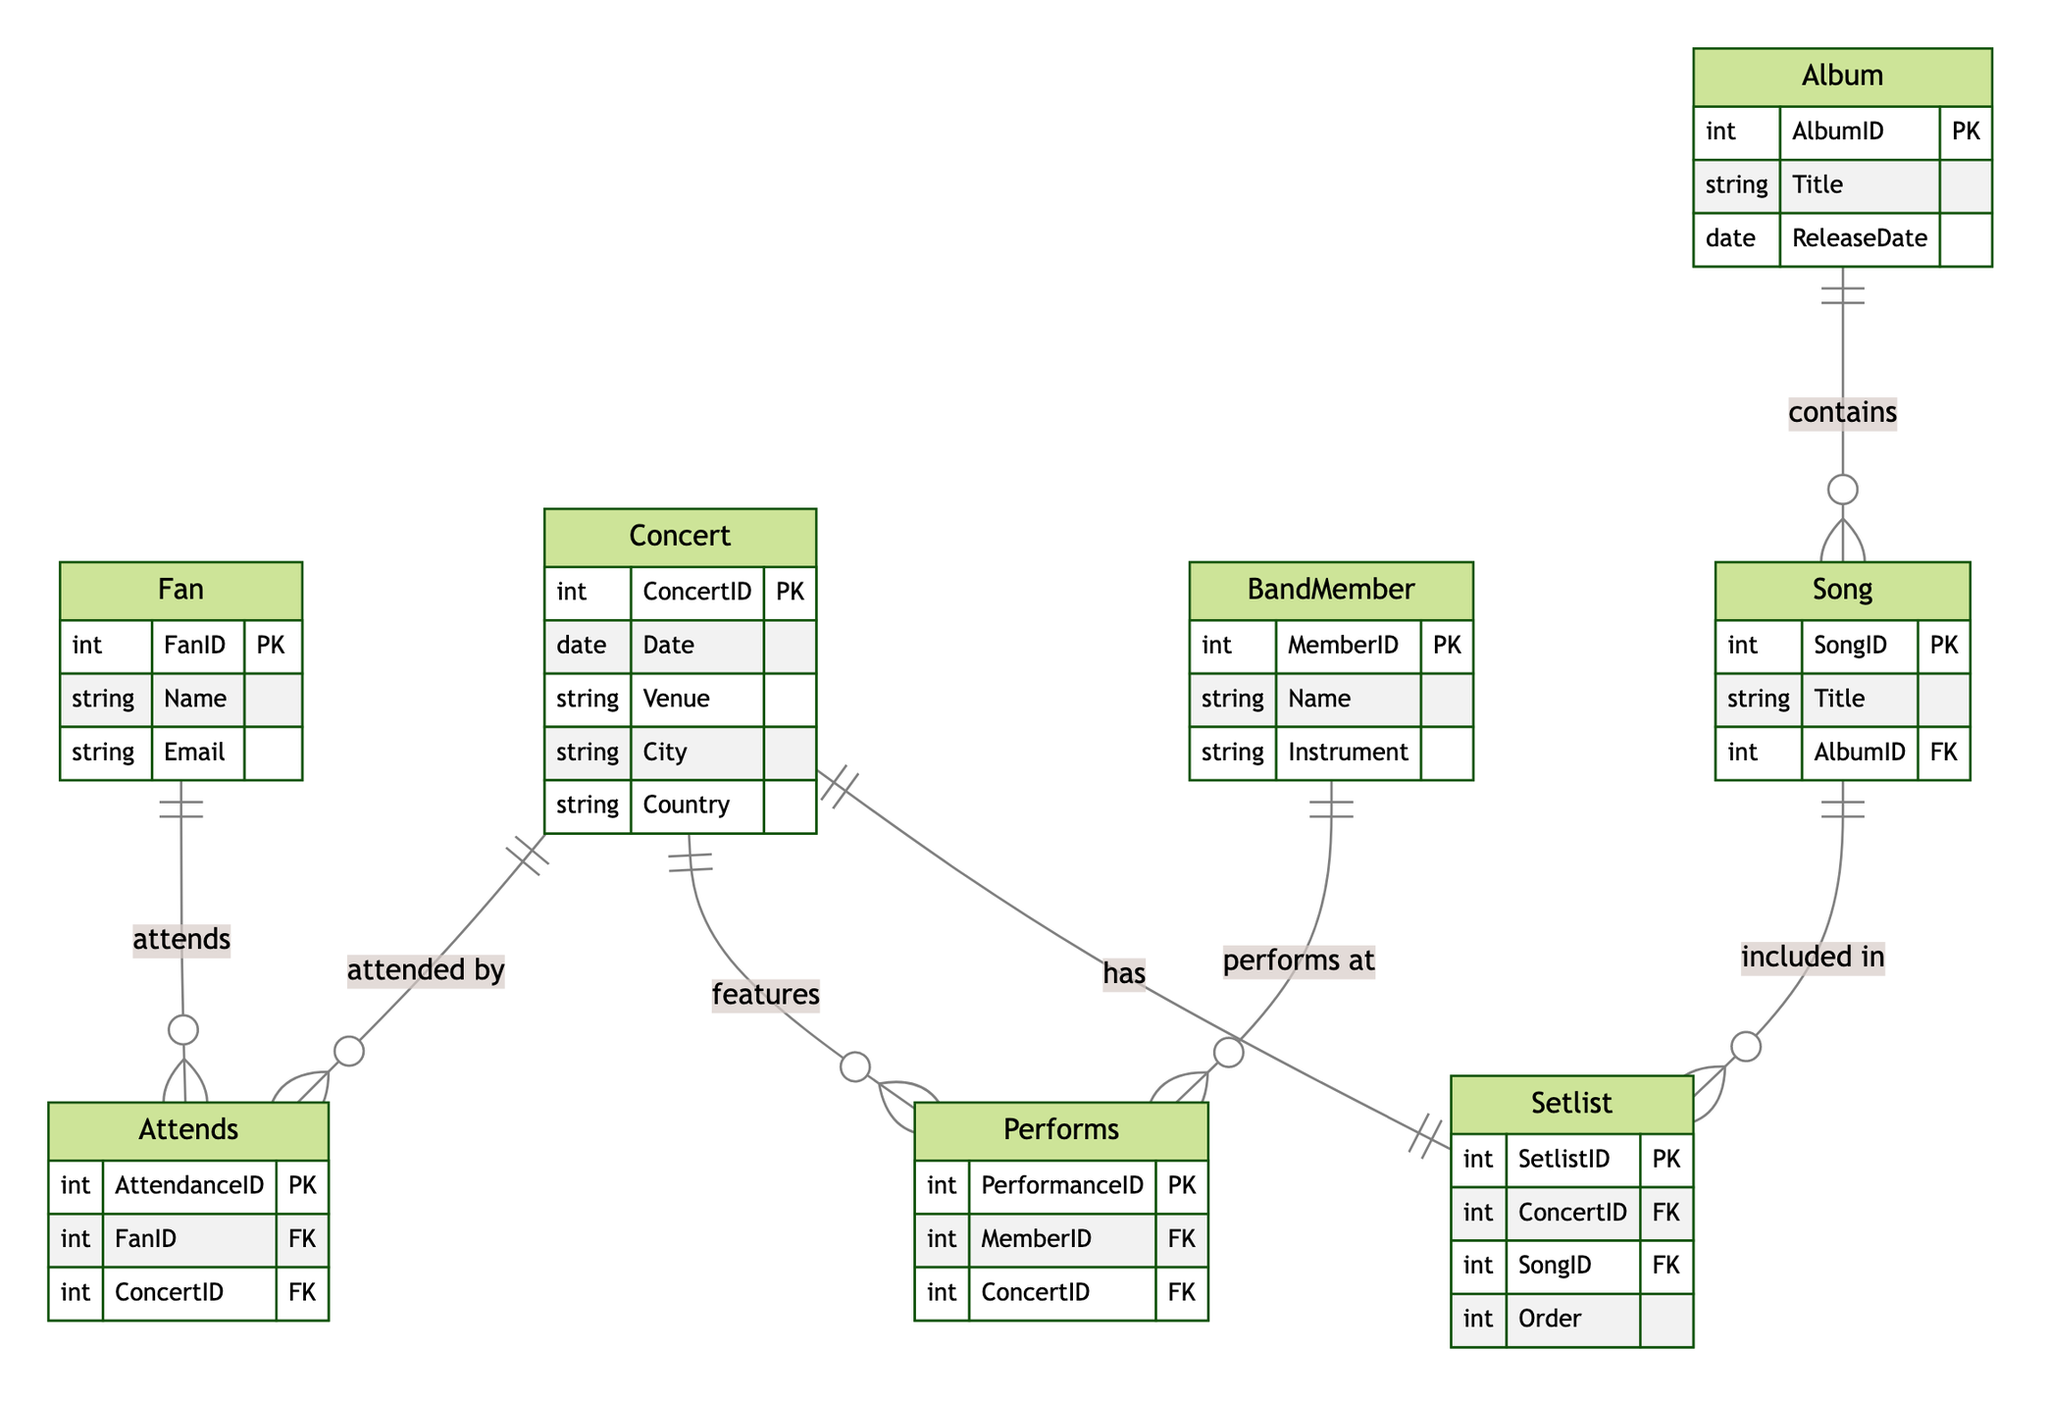What is the primary key of the Fan entity? The primary key of the Fan entity is specified as "FanID" in the diagram, which uniquely identifies each Fan in the system.
Answer: FanID How many attributes does the Concert entity have? The Concert entity contains 5 attributes: ConcertID, Date, Venue, City, and Country. By counting these attributes, we determine the total.
Answer: 5 What is the relationship between the Fan and Concert entities? The relationship is defined by the "Attends" entity, which connects Fans to Concerts indicating that a Fan can attend a Concert.
Answer: Attends Which entity contains the attribute 'Title' related to songs? The Song entity contains the attribute 'Title', indicating that it represents individual songs with their titles noted explicitly.
Answer: Song How many relationships connect to the Concert entity? The Concert entity is connected to 4 relationships: Attends, Performs, Setlist, and Includes, indicating its involvement in various aspects of the concert experience.
Answer: 4 Which entity can a Song belong to? A Song can belong to an Album as indicated by the "Includes" relationship, which connects Albums to Songs to show ownership.
Answer: Album What does the Setlist entity have in common with the Concert entity? The Setlist entity has a relationship with the Concert entity, showing that a Setlist is associated with a specific Concert.
Answer: Has Which entity features the most detailed attribute data in this diagram? The BandMember entity features three detailed attributes: MemberID, Name, and Instrument, specifying important information about each band member.
Answer: BandMember What is the primary purpose of the Plays relationship? The Plays relationship defines how Songs are included in a Setlist, detailing the inclusion of specific songs in specific concert setlists.
Answer: Included in What primary key is associated with the AttendanceID in the Attends relationship? The primary key associated with AttendanceID in the Attends relationship uniquely identifies each attendance record, indicating that it connects a Fan to a Concert.
Answer: AttendanceID 